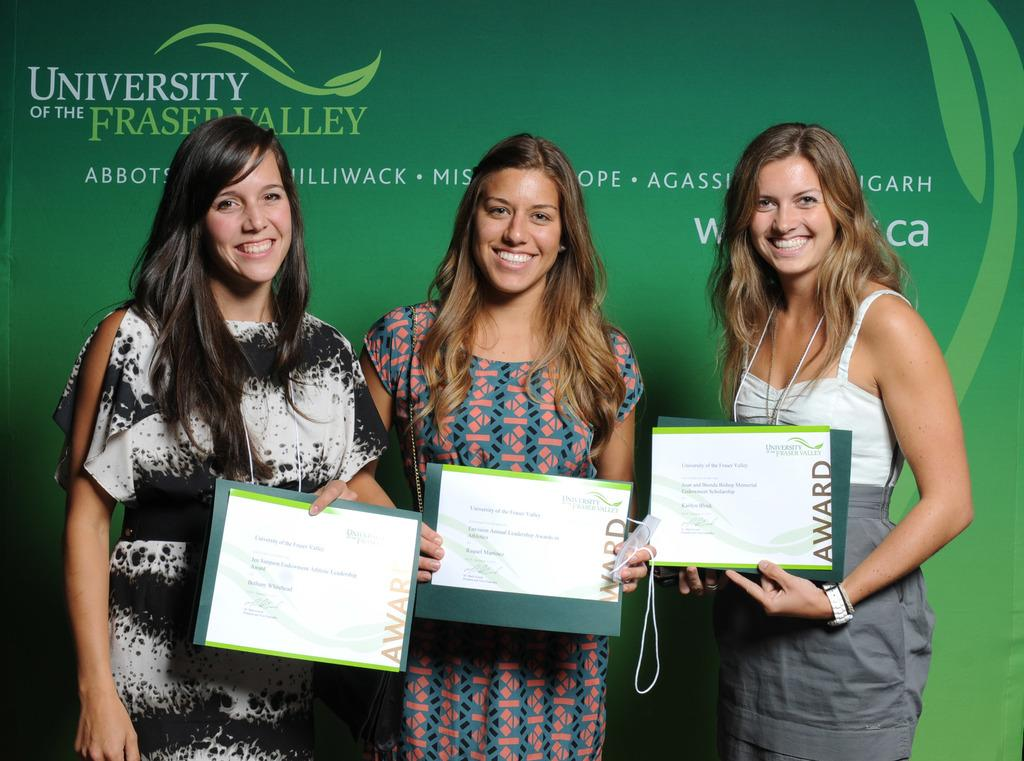How many people are in the image? There are three ladies in the image. What are the ladies holding in the image? The ladies are holding posters. Can you describe the poster in the background of the image? There is a green color poster with text in the background of the image. What is the grandmother's opinion on the queen's digestion in the image? There is no grandmother or queen present in the image, and therefore no such conversation can be observed. 